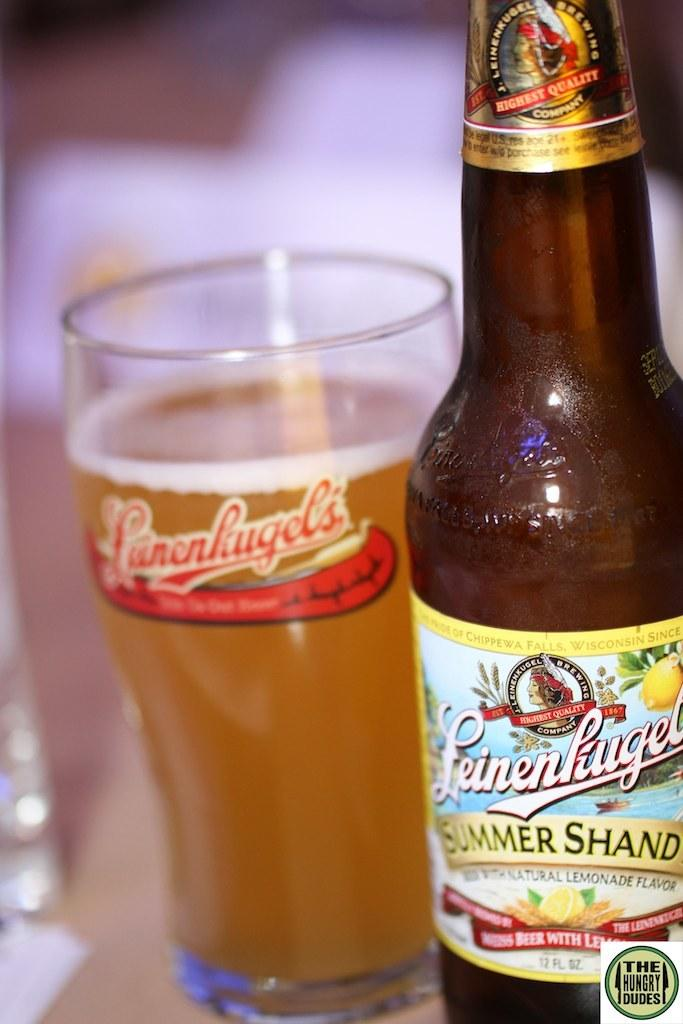<image>
Provide a brief description of the given image. A Leienhugels summer shand beer bottle next to a filled Leinenhugel's glass. 